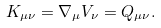Convert formula to latex. <formula><loc_0><loc_0><loc_500><loc_500>K _ { \mu \nu } = \nabla _ { \mu } V _ { \nu } = Q _ { \mu \nu } .</formula> 